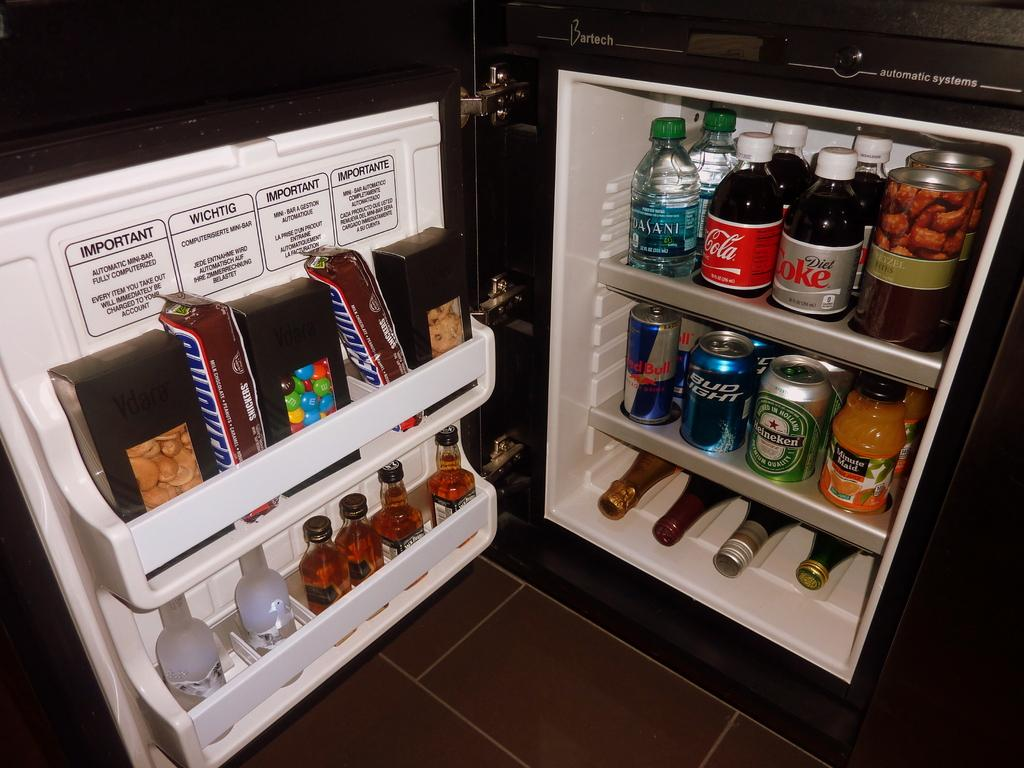<image>
Provide a brief description of the given image. A fridge with may drinks such as Diet Coke inside. 